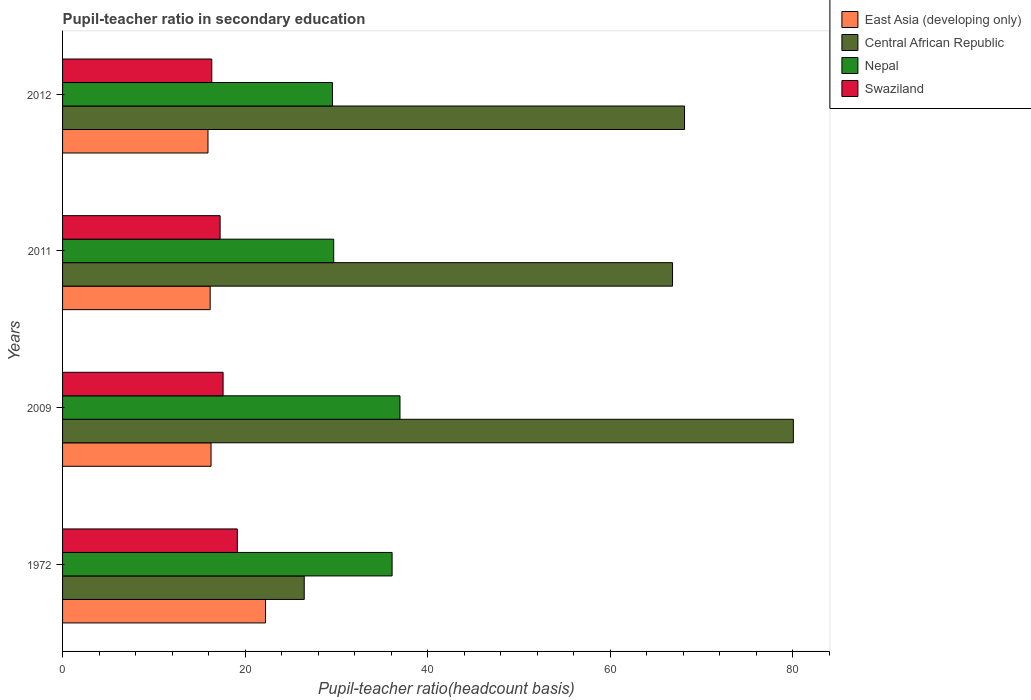How many groups of bars are there?
Give a very brief answer. 4. How many bars are there on the 1st tick from the bottom?
Your answer should be very brief. 4. What is the label of the 4th group of bars from the top?
Offer a very short reply. 1972. In how many cases, is the number of bars for a given year not equal to the number of legend labels?
Your answer should be very brief. 0. What is the pupil-teacher ratio in secondary education in East Asia (developing only) in 2009?
Provide a succinct answer. 16.26. Across all years, what is the maximum pupil-teacher ratio in secondary education in Nepal?
Give a very brief answer. 36.96. Across all years, what is the minimum pupil-teacher ratio in secondary education in Swaziland?
Provide a short and direct response. 16.35. In which year was the pupil-teacher ratio in secondary education in Central African Republic maximum?
Keep it short and to the point. 2009. In which year was the pupil-teacher ratio in secondary education in Nepal minimum?
Ensure brevity in your answer.  2012. What is the total pupil-teacher ratio in secondary education in East Asia (developing only) in the graph?
Your response must be concise. 70.59. What is the difference between the pupil-teacher ratio in secondary education in Central African Republic in 2009 and that in 2012?
Keep it short and to the point. 11.92. What is the difference between the pupil-teacher ratio in secondary education in Central African Republic in 2011 and the pupil-teacher ratio in secondary education in Nepal in 1972?
Keep it short and to the point. 30.72. What is the average pupil-teacher ratio in secondary education in East Asia (developing only) per year?
Give a very brief answer. 17.65. In the year 1972, what is the difference between the pupil-teacher ratio in secondary education in Swaziland and pupil-teacher ratio in secondary education in Central African Republic?
Ensure brevity in your answer.  -7.33. In how many years, is the pupil-teacher ratio in secondary education in East Asia (developing only) greater than 44 ?
Your answer should be very brief. 0. What is the ratio of the pupil-teacher ratio in secondary education in East Asia (developing only) in 2009 to that in 2011?
Offer a terse response. 1.01. Is the pupil-teacher ratio in secondary education in Nepal in 2011 less than that in 2012?
Give a very brief answer. No. Is the difference between the pupil-teacher ratio in secondary education in Swaziland in 1972 and 2011 greater than the difference between the pupil-teacher ratio in secondary education in Central African Republic in 1972 and 2011?
Offer a very short reply. Yes. What is the difference between the highest and the second highest pupil-teacher ratio in secondary education in Nepal?
Your answer should be compact. 0.86. What is the difference between the highest and the lowest pupil-teacher ratio in secondary education in Nepal?
Make the answer very short. 7.4. Is the sum of the pupil-teacher ratio in secondary education in East Asia (developing only) in 2011 and 2012 greater than the maximum pupil-teacher ratio in secondary education in Swaziland across all years?
Your answer should be compact. Yes. Is it the case that in every year, the sum of the pupil-teacher ratio in secondary education in Swaziland and pupil-teacher ratio in secondary education in East Asia (developing only) is greater than the sum of pupil-teacher ratio in secondary education in Nepal and pupil-teacher ratio in secondary education in Central African Republic?
Provide a short and direct response. No. What does the 2nd bar from the top in 2011 represents?
Ensure brevity in your answer.  Nepal. What does the 2nd bar from the bottom in 2011 represents?
Make the answer very short. Central African Republic. Is it the case that in every year, the sum of the pupil-teacher ratio in secondary education in Nepal and pupil-teacher ratio in secondary education in Central African Republic is greater than the pupil-teacher ratio in secondary education in East Asia (developing only)?
Ensure brevity in your answer.  Yes. How many bars are there?
Your answer should be compact. 16. How many years are there in the graph?
Make the answer very short. 4. Are the values on the major ticks of X-axis written in scientific E-notation?
Offer a very short reply. No. Does the graph contain grids?
Your answer should be very brief. No. How are the legend labels stacked?
Give a very brief answer. Vertical. What is the title of the graph?
Offer a very short reply. Pupil-teacher ratio in secondary education. What is the label or title of the X-axis?
Provide a succinct answer. Pupil-teacher ratio(headcount basis). What is the label or title of the Y-axis?
Give a very brief answer. Years. What is the Pupil-teacher ratio(headcount basis) of East Asia (developing only) in 1972?
Ensure brevity in your answer.  22.23. What is the Pupil-teacher ratio(headcount basis) of Central African Republic in 1972?
Provide a succinct answer. 26.47. What is the Pupil-teacher ratio(headcount basis) in Nepal in 1972?
Provide a succinct answer. 36.1. What is the Pupil-teacher ratio(headcount basis) in Swaziland in 1972?
Provide a short and direct response. 19.15. What is the Pupil-teacher ratio(headcount basis) in East Asia (developing only) in 2009?
Your answer should be compact. 16.26. What is the Pupil-teacher ratio(headcount basis) in Central African Republic in 2009?
Provide a short and direct response. 80.05. What is the Pupil-teacher ratio(headcount basis) of Nepal in 2009?
Ensure brevity in your answer.  36.96. What is the Pupil-teacher ratio(headcount basis) of Swaziland in 2009?
Offer a very short reply. 17.58. What is the Pupil-teacher ratio(headcount basis) in East Asia (developing only) in 2011?
Your answer should be compact. 16.17. What is the Pupil-teacher ratio(headcount basis) of Central African Republic in 2011?
Provide a short and direct response. 66.82. What is the Pupil-teacher ratio(headcount basis) of Nepal in 2011?
Your response must be concise. 29.7. What is the Pupil-teacher ratio(headcount basis) of Swaziland in 2011?
Keep it short and to the point. 17.26. What is the Pupil-teacher ratio(headcount basis) in East Asia (developing only) in 2012?
Ensure brevity in your answer.  15.93. What is the Pupil-teacher ratio(headcount basis) in Central African Republic in 2012?
Your response must be concise. 68.13. What is the Pupil-teacher ratio(headcount basis) of Nepal in 2012?
Give a very brief answer. 29.56. What is the Pupil-teacher ratio(headcount basis) of Swaziland in 2012?
Your answer should be very brief. 16.35. Across all years, what is the maximum Pupil-teacher ratio(headcount basis) of East Asia (developing only)?
Offer a very short reply. 22.23. Across all years, what is the maximum Pupil-teacher ratio(headcount basis) in Central African Republic?
Keep it short and to the point. 80.05. Across all years, what is the maximum Pupil-teacher ratio(headcount basis) in Nepal?
Offer a very short reply. 36.96. Across all years, what is the maximum Pupil-teacher ratio(headcount basis) of Swaziland?
Provide a succinct answer. 19.15. Across all years, what is the minimum Pupil-teacher ratio(headcount basis) of East Asia (developing only)?
Offer a terse response. 15.93. Across all years, what is the minimum Pupil-teacher ratio(headcount basis) in Central African Republic?
Make the answer very short. 26.47. Across all years, what is the minimum Pupil-teacher ratio(headcount basis) of Nepal?
Give a very brief answer. 29.56. Across all years, what is the minimum Pupil-teacher ratio(headcount basis) of Swaziland?
Make the answer very short. 16.35. What is the total Pupil-teacher ratio(headcount basis) of East Asia (developing only) in the graph?
Your answer should be very brief. 70.59. What is the total Pupil-teacher ratio(headcount basis) of Central African Republic in the graph?
Offer a terse response. 241.47. What is the total Pupil-teacher ratio(headcount basis) of Nepal in the graph?
Your answer should be compact. 132.32. What is the total Pupil-teacher ratio(headcount basis) of Swaziland in the graph?
Provide a short and direct response. 70.33. What is the difference between the Pupil-teacher ratio(headcount basis) of East Asia (developing only) in 1972 and that in 2009?
Keep it short and to the point. 5.97. What is the difference between the Pupil-teacher ratio(headcount basis) in Central African Republic in 1972 and that in 2009?
Your response must be concise. -53.58. What is the difference between the Pupil-teacher ratio(headcount basis) in Nepal in 1972 and that in 2009?
Make the answer very short. -0.86. What is the difference between the Pupil-teacher ratio(headcount basis) of Swaziland in 1972 and that in 2009?
Your answer should be compact. 1.56. What is the difference between the Pupil-teacher ratio(headcount basis) of East Asia (developing only) in 1972 and that in 2011?
Ensure brevity in your answer.  6.06. What is the difference between the Pupil-teacher ratio(headcount basis) in Central African Republic in 1972 and that in 2011?
Offer a terse response. -40.34. What is the difference between the Pupil-teacher ratio(headcount basis) in Nepal in 1972 and that in 2011?
Offer a very short reply. 6.4. What is the difference between the Pupil-teacher ratio(headcount basis) in Swaziland in 1972 and that in 2011?
Your answer should be compact. 1.89. What is the difference between the Pupil-teacher ratio(headcount basis) of East Asia (developing only) in 1972 and that in 2012?
Your answer should be compact. 6.3. What is the difference between the Pupil-teacher ratio(headcount basis) of Central African Republic in 1972 and that in 2012?
Provide a succinct answer. -41.66. What is the difference between the Pupil-teacher ratio(headcount basis) of Nepal in 1972 and that in 2012?
Make the answer very short. 6.53. What is the difference between the Pupil-teacher ratio(headcount basis) in Swaziland in 1972 and that in 2012?
Provide a succinct answer. 2.8. What is the difference between the Pupil-teacher ratio(headcount basis) in East Asia (developing only) in 2009 and that in 2011?
Your answer should be compact. 0.1. What is the difference between the Pupil-teacher ratio(headcount basis) of Central African Republic in 2009 and that in 2011?
Give a very brief answer. 13.24. What is the difference between the Pupil-teacher ratio(headcount basis) of Nepal in 2009 and that in 2011?
Give a very brief answer. 7.26. What is the difference between the Pupil-teacher ratio(headcount basis) of Swaziland in 2009 and that in 2011?
Give a very brief answer. 0.33. What is the difference between the Pupil-teacher ratio(headcount basis) in East Asia (developing only) in 2009 and that in 2012?
Give a very brief answer. 0.34. What is the difference between the Pupil-teacher ratio(headcount basis) of Central African Republic in 2009 and that in 2012?
Your answer should be compact. 11.92. What is the difference between the Pupil-teacher ratio(headcount basis) in Nepal in 2009 and that in 2012?
Offer a terse response. 7.4. What is the difference between the Pupil-teacher ratio(headcount basis) of Swaziland in 2009 and that in 2012?
Make the answer very short. 1.24. What is the difference between the Pupil-teacher ratio(headcount basis) in East Asia (developing only) in 2011 and that in 2012?
Offer a terse response. 0.24. What is the difference between the Pupil-teacher ratio(headcount basis) of Central African Republic in 2011 and that in 2012?
Provide a short and direct response. -1.31. What is the difference between the Pupil-teacher ratio(headcount basis) of Nepal in 2011 and that in 2012?
Your response must be concise. 0.14. What is the difference between the Pupil-teacher ratio(headcount basis) of Swaziland in 2011 and that in 2012?
Offer a terse response. 0.91. What is the difference between the Pupil-teacher ratio(headcount basis) in East Asia (developing only) in 1972 and the Pupil-teacher ratio(headcount basis) in Central African Republic in 2009?
Offer a terse response. -57.82. What is the difference between the Pupil-teacher ratio(headcount basis) of East Asia (developing only) in 1972 and the Pupil-teacher ratio(headcount basis) of Nepal in 2009?
Your answer should be compact. -14.73. What is the difference between the Pupil-teacher ratio(headcount basis) in East Asia (developing only) in 1972 and the Pupil-teacher ratio(headcount basis) in Swaziland in 2009?
Offer a very short reply. 4.65. What is the difference between the Pupil-teacher ratio(headcount basis) in Central African Republic in 1972 and the Pupil-teacher ratio(headcount basis) in Nepal in 2009?
Provide a short and direct response. -10.49. What is the difference between the Pupil-teacher ratio(headcount basis) in Central African Republic in 1972 and the Pupil-teacher ratio(headcount basis) in Swaziland in 2009?
Make the answer very short. 8.89. What is the difference between the Pupil-teacher ratio(headcount basis) in Nepal in 1972 and the Pupil-teacher ratio(headcount basis) in Swaziland in 2009?
Your response must be concise. 18.51. What is the difference between the Pupil-teacher ratio(headcount basis) in East Asia (developing only) in 1972 and the Pupil-teacher ratio(headcount basis) in Central African Republic in 2011?
Provide a short and direct response. -44.59. What is the difference between the Pupil-teacher ratio(headcount basis) of East Asia (developing only) in 1972 and the Pupil-teacher ratio(headcount basis) of Nepal in 2011?
Your answer should be very brief. -7.47. What is the difference between the Pupil-teacher ratio(headcount basis) of East Asia (developing only) in 1972 and the Pupil-teacher ratio(headcount basis) of Swaziland in 2011?
Provide a succinct answer. 4.97. What is the difference between the Pupil-teacher ratio(headcount basis) in Central African Republic in 1972 and the Pupil-teacher ratio(headcount basis) in Nepal in 2011?
Provide a short and direct response. -3.23. What is the difference between the Pupil-teacher ratio(headcount basis) of Central African Republic in 1972 and the Pupil-teacher ratio(headcount basis) of Swaziland in 2011?
Keep it short and to the point. 9.21. What is the difference between the Pupil-teacher ratio(headcount basis) of Nepal in 1972 and the Pupil-teacher ratio(headcount basis) of Swaziland in 2011?
Offer a very short reply. 18.84. What is the difference between the Pupil-teacher ratio(headcount basis) of East Asia (developing only) in 1972 and the Pupil-teacher ratio(headcount basis) of Central African Republic in 2012?
Provide a succinct answer. -45.9. What is the difference between the Pupil-teacher ratio(headcount basis) of East Asia (developing only) in 1972 and the Pupil-teacher ratio(headcount basis) of Nepal in 2012?
Keep it short and to the point. -7.33. What is the difference between the Pupil-teacher ratio(headcount basis) in East Asia (developing only) in 1972 and the Pupil-teacher ratio(headcount basis) in Swaziland in 2012?
Keep it short and to the point. 5.89. What is the difference between the Pupil-teacher ratio(headcount basis) in Central African Republic in 1972 and the Pupil-teacher ratio(headcount basis) in Nepal in 2012?
Make the answer very short. -3.09. What is the difference between the Pupil-teacher ratio(headcount basis) of Central African Republic in 1972 and the Pupil-teacher ratio(headcount basis) of Swaziland in 2012?
Offer a very short reply. 10.13. What is the difference between the Pupil-teacher ratio(headcount basis) in Nepal in 1972 and the Pupil-teacher ratio(headcount basis) in Swaziland in 2012?
Your answer should be very brief. 19.75. What is the difference between the Pupil-teacher ratio(headcount basis) of East Asia (developing only) in 2009 and the Pupil-teacher ratio(headcount basis) of Central African Republic in 2011?
Offer a terse response. -50.55. What is the difference between the Pupil-teacher ratio(headcount basis) in East Asia (developing only) in 2009 and the Pupil-teacher ratio(headcount basis) in Nepal in 2011?
Provide a short and direct response. -13.44. What is the difference between the Pupil-teacher ratio(headcount basis) of East Asia (developing only) in 2009 and the Pupil-teacher ratio(headcount basis) of Swaziland in 2011?
Provide a succinct answer. -0.99. What is the difference between the Pupil-teacher ratio(headcount basis) in Central African Republic in 2009 and the Pupil-teacher ratio(headcount basis) in Nepal in 2011?
Your response must be concise. 50.35. What is the difference between the Pupil-teacher ratio(headcount basis) in Central African Republic in 2009 and the Pupil-teacher ratio(headcount basis) in Swaziland in 2011?
Make the answer very short. 62.79. What is the difference between the Pupil-teacher ratio(headcount basis) of Nepal in 2009 and the Pupil-teacher ratio(headcount basis) of Swaziland in 2011?
Offer a terse response. 19.7. What is the difference between the Pupil-teacher ratio(headcount basis) in East Asia (developing only) in 2009 and the Pupil-teacher ratio(headcount basis) in Central African Republic in 2012?
Provide a short and direct response. -51.87. What is the difference between the Pupil-teacher ratio(headcount basis) in East Asia (developing only) in 2009 and the Pupil-teacher ratio(headcount basis) in Nepal in 2012?
Ensure brevity in your answer.  -13.3. What is the difference between the Pupil-teacher ratio(headcount basis) in East Asia (developing only) in 2009 and the Pupil-teacher ratio(headcount basis) in Swaziland in 2012?
Provide a succinct answer. -0.08. What is the difference between the Pupil-teacher ratio(headcount basis) in Central African Republic in 2009 and the Pupil-teacher ratio(headcount basis) in Nepal in 2012?
Keep it short and to the point. 50.49. What is the difference between the Pupil-teacher ratio(headcount basis) of Central African Republic in 2009 and the Pupil-teacher ratio(headcount basis) of Swaziland in 2012?
Provide a succinct answer. 63.71. What is the difference between the Pupil-teacher ratio(headcount basis) of Nepal in 2009 and the Pupil-teacher ratio(headcount basis) of Swaziland in 2012?
Provide a succinct answer. 20.62. What is the difference between the Pupil-teacher ratio(headcount basis) of East Asia (developing only) in 2011 and the Pupil-teacher ratio(headcount basis) of Central African Republic in 2012?
Give a very brief answer. -51.96. What is the difference between the Pupil-teacher ratio(headcount basis) of East Asia (developing only) in 2011 and the Pupil-teacher ratio(headcount basis) of Nepal in 2012?
Provide a succinct answer. -13.4. What is the difference between the Pupil-teacher ratio(headcount basis) of East Asia (developing only) in 2011 and the Pupil-teacher ratio(headcount basis) of Swaziland in 2012?
Ensure brevity in your answer.  -0.18. What is the difference between the Pupil-teacher ratio(headcount basis) in Central African Republic in 2011 and the Pupil-teacher ratio(headcount basis) in Nepal in 2012?
Make the answer very short. 37.25. What is the difference between the Pupil-teacher ratio(headcount basis) of Central African Republic in 2011 and the Pupil-teacher ratio(headcount basis) of Swaziland in 2012?
Give a very brief answer. 50.47. What is the difference between the Pupil-teacher ratio(headcount basis) in Nepal in 2011 and the Pupil-teacher ratio(headcount basis) in Swaziland in 2012?
Give a very brief answer. 13.36. What is the average Pupil-teacher ratio(headcount basis) in East Asia (developing only) per year?
Offer a very short reply. 17.65. What is the average Pupil-teacher ratio(headcount basis) in Central African Republic per year?
Your answer should be compact. 60.37. What is the average Pupil-teacher ratio(headcount basis) in Nepal per year?
Your response must be concise. 33.08. What is the average Pupil-teacher ratio(headcount basis) of Swaziland per year?
Provide a short and direct response. 17.58. In the year 1972, what is the difference between the Pupil-teacher ratio(headcount basis) of East Asia (developing only) and Pupil-teacher ratio(headcount basis) of Central African Republic?
Offer a terse response. -4.24. In the year 1972, what is the difference between the Pupil-teacher ratio(headcount basis) of East Asia (developing only) and Pupil-teacher ratio(headcount basis) of Nepal?
Your answer should be compact. -13.87. In the year 1972, what is the difference between the Pupil-teacher ratio(headcount basis) of East Asia (developing only) and Pupil-teacher ratio(headcount basis) of Swaziland?
Your answer should be very brief. 3.09. In the year 1972, what is the difference between the Pupil-teacher ratio(headcount basis) in Central African Republic and Pupil-teacher ratio(headcount basis) in Nepal?
Provide a short and direct response. -9.62. In the year 1972, what is the difference between the Pupil-teacher ratio(headcount basis) in Central African Republic and Pupil-teacher ratio(headcount basis) in Swaziland?
Your answer should be very brief. 7.33. In the year 1972, what is the difference between the Pupil-teacher ratio(headcount basis) in Nepal and Pupil-teacher ratio(headcount basis) in Swaziland?
Make the answer very short. 16.95. In the year 2009, what is the difference between the Pupil-teacher ratio(headcount basis) of East Asia (developing only) and Pupil-teacher ratio(headcount basis) of Central African Republic?
Your answer should be compact. -63.79. In the year 2009, what is the difference between the Pupil-teacher ratio(headcount basis) in East Asia (developing only) and Pupil-teacher ratio(headcount basis) in Nepal?
Offer a terse response. -20.7. In the year 2009, what is the difference between the Pupil-teacher ratio(headcount basis) in East Asia (developing only) and Pupil-teacher ratio(headcount basis) in Swaziland?
Provide a short and direct response. -1.32. In the year 2009, what is the difference between the Pupil-teacher ratio(headcount basis) of Central African Republic and Pupil-teacher ratio(headcount basis) of Nepal?
Give a very brief answer. 43.09. In the year 2009, what is the difference between the Pupil-teacher ratio(headcount basis) of Central African Republic and Pupil-teacher ratio(headcount basis) of Swaziland?
Ensure brevity in your answer.  62.47. In the year 2009, what is the difference between the Pupil-teacher ratio(headcount basis) of Nepal and Pupil-teacher ratio(headcount basis) of Swaziland?
Ensure brevity in your answer.  19.38. In the year 2011, what is the difference between the Pupil-teacher ratio(headcount basis) of East Asia (developing only) and Pupil-teacher ratio(headcount basis) of Central African Republic?
Your answer should be compact. -50.65. In the year 2011, what is the difference between the Pupil-teacher ratio(headcount basis) of East Asia (developing only) and Pupil-teacher ratio(headcount basis) of Nepal?
Your answer should be very brief. -13.53. In the year 2011, what is the difference between the Pupil-teacher ratio(headcount basis) in East Asia (developing only) and Pupil-teacher ratio(headcount basis) in Swaziland?
Give a very brief answer. -1.09. In the year 2011, what is the difference between the Pupil-teacher ratio(headcount basis) of Central African Republic and Pupil-teacher ratio(headcount basis) of Nepal?
Keep it short and to the point. 37.12. In the year 2011, what is the difference between the Pupil-teacher ratio(headcount basis) in Central African Republic and Pupil-teacher ratio(headcount basis) in Swaziland?
Your answer should be very brief. 49.56. In the year 2011, what is the difference between the Pupil-teacher ratio(headcount basis) of Nepal and Pupil-teacher ratio(headcount basis) of Swaziland?
Ensure brevity in your answer.  12.44. In the year 2012, what is the difference between the Pupil-teacher ratio(headcount basis) in East Asia (developing only) and Pupil-teacher ratio(headcount basis) in Central African Republic?
Your answer should be compact. -52.2. In the year 2012, what is the difference between the Pupil-teacher ratio(headcount basis) of East Asia (developing only) and Pupil-teacher ratio(headcount basis) of Nepal?
Make the answer very short. -13.63. In the year 2012, what is the difference between the Pupil-teacher ratio(headcount basis) in East Asia (developing only) and Pupil-teacher ratio(headcount basis) in Swaziland?
Your response must be concise. -0.42. In the year 2012, what is the difference between the Pupil-teacher ratio(headcount basis) in Central African Republic and Pupil-teacher ratio(headcount basis) in Nepal?
Your answer should be compact. 38.57. In the year 2012, what is the difference between the Pupil-teacher ratio(headcount basis) of Central African Republic and Pupil-teacher ratio(headcount basis) of Swaziland?
Your answer should be compact. 51.79. In the year 2012, what is the difference between the Pupil-teacher ratio(headcount basis) in Nepal and Pupil-teacher ratio(headcount basis) in Swaziland?
Provide a succinct answer. 13.22. What is the ratio of the Pupil-teacher ratio(headcount basis) in East Asia (developing only) in 1972 to that in 2009?
Your response must be concise. 1.37. What is the ratio of the Pupil-teacher ratio(headcount basis) in Central African Republic in 1972 to that in 2009?
Provide a succinct answer. 0.33. What is the ratio of the Pupil-teacher ratio(headcount basis) of Nepal in 1972 to that in 2009?
Provide a succinct answer. 0.98. What is the ratio of the Pupil-teacher ratio(headcount basis) in Swaziland in 1972 to that in 2009?
Give a very brief answer. 1.09. What is the ratio of the Pupil-teacher ratio(headcount basis) in East Asia (developing only) in 1972 to that in 2011?
Keep it short and to the point. 1.38. What is the ratio of the Pupil-teacher ratio(headcount basis) of Central African Republic in 1972 to that in 2011?
Your answer should be very brief. 0.4. What is the ratio of the Pupil-teacher ratio(headcount basis) of Nepal in 1972 to that in 2011?
Offer a terse response. 1.22. What is the ratio of the Pupil-teacher ratio(headcount basis) in Swaziland in 1972 to that in 2011?
Make the answer very short. 1.11. What is the ratio of the Pupil-teacher ratio(headcount basis) in East Asia (developing only) in 1972 to that in 2012?
Your answer should be very brief. 1.4. What is the ratio of the Pupil-teacher ratio(headcount basis) in Central African Republic in 1972 to that in 2012?
Your answer should be very brief. 0.39. What is the ratio of the Pupil-teacher ratio(headcount basis) of Nepal in 1972 to that in 2012?
Offer a very short reply. 1.22. What is the ratio of the Pupil-teacher ratio(headcount basis) in Swaziland in 1972 to that in 2012?
Your answer should be compact. 1.17. What is the ratio of the Pupil-teacher ratio(headcount basis) in East Asia (developing only) in 2009 to that in 2011?
Ensure brevity in your answer.  1.01. What is the ratio of the Pupil-teacher ratio(headcount basis) in Central African Republic in 2009 to that in 2011?
Your answer should be compact. 1.2. What is the ratio of the Pupil-teacher ratio(headcount basis) of Nepal in 2009 to that in 2011?
Your response must be concise. 1.24. What is the ratio of the Pupil-teacher ratio(headcount basis) of Swaziland in 2009 to that in 2011?
Your answer should be very brief. 1.02. What is the ratio of the Pupil-teacher ratio(headcount basis) in Central African Republic in 2009 to that in 2012?
Your answer should be very brief. 1.18. What is the ratio of the Pupil-teacher ratio(headcount basis) in Nepal in 2009 to that in 2012?
Keep it short and to the point. 1.25. What is the ratio of the Pupil-teacher ratio(headcount basis) of Swaziland in 2009 to that in 2012?
Make the answer very short. 1.08. What is the ratio of the Pupil-teacher ratio(headcount basis) of Central African Republic in 2011 to that in 2012?
Offer a very short reply. 0.98. What is the ratio of the Pupil-teacher ratio(headcount basis) of Nepal in 2011 to that in 2012?
Your answer should be compact. 1. What is the ratio of the Pupil-teacher ratio(headcount basis) of Swaziland in 2011 to that in 2012?
Your answer should be compact. 1.06. What is the difference between the highest and the second highest Pupil-teacher ratio(headcount basis) in East Asia (developing only)?
Your answer should be compact. 5.97. What is the difference between the highest and the second highest Pupil-teacher ratio(headcount basis) in Central African Republic?
Offer a very short reply. 11.92. What is the difference between the highest and the second highest Pupil-teacher ratio(headcount basis) in Nepal?
Keep it short and to the point. 0.86. What is the difference between the highest and the second highest Pupil-teacher ratio(headcount basis) in Swaziland?
Your answer should be very brief. 1.56. What is the difference between the highest and the lowest Pupil-teacher ratio(headcount basis) in East Asia (developing only)?
Offer a very short reply. 6.3. What is the difference between the highest and the lowest Pupil-teacher ratio(headcount basis) of Central African Republic?
Offer a terse response. 53.58. What is the difference between the highest and the lowest Pupil-teacher ratio(headcount basis) of Nepal?
Provide a short and direct response. 7.4. What is the difference between the highest and the lowest Pupil-teacher ratio(headcount basis) in Swaziland?
Make the answer very short. 2.8. 